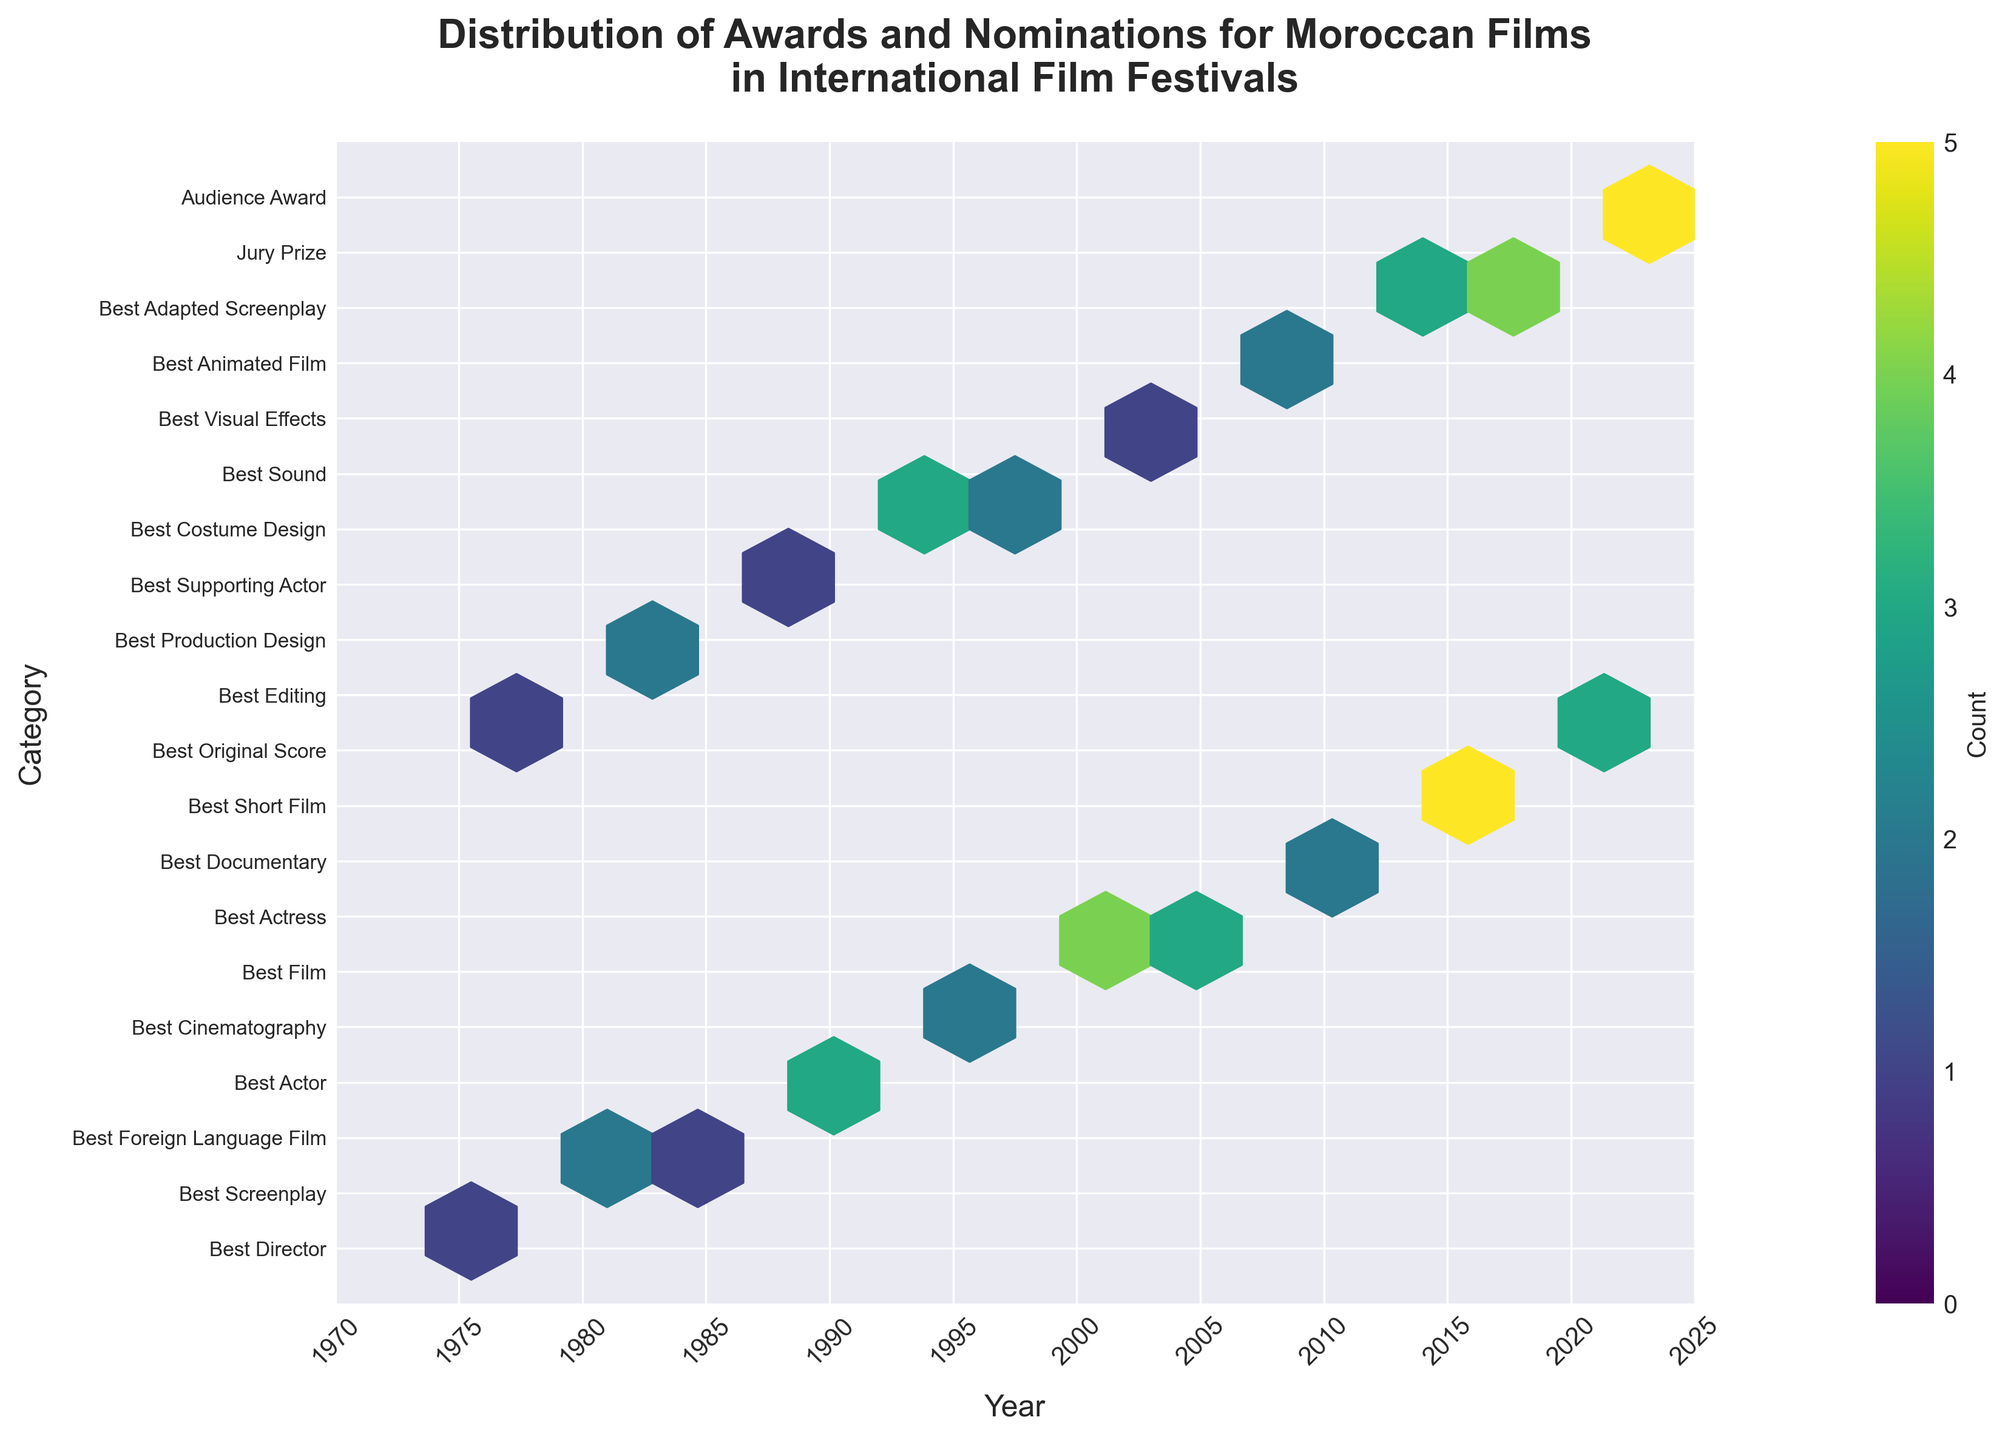What is the title of the figure? The title can be found at the top of the figure, which describes what the figure is about.
Answer: Distribution of Awards and Nominations for Moroccan Films in International Film Festivals What is the color range used in the hexbin plot? The color range usually denotes the count of awards and nominations, mapped to a colormap mentioned in the guide. The plot uses a color spectrum from the colormap indicated.
Answer: viridis What are the x-axis and y-axis labels? The labels can be found along the axes, describing what each axis represents.
Answer: Year and Category How many categories are present in the plot? Count the number of unique tick labels along the y-axis.
Answer: 20 Which category had the highest count of awards or nominations in 2015? Find the y-axis category that aligns with the hexbin on the x-axis value of 2015 and has the highest color intensity.
Answer: Best Short Film Is there a category that won awards or nominations consistently over many years? Look for categories on the y-axis that have multiple hexbins with higher counts spread across different years on the x-axis.
Answer: Examples would require specific attention, but count occurrences per category Does the plot show any award counts that are equal to 5? The color bar indicates the count of awards, locate the hexbins on the plot with the same color intensity as specified on the color bar reading 5.
Answer: Yes What was the count of "Best Adapted Screenplay" nominations in 2013? Match the y-axis of "Best Adapted Screenplay" with the x-axis of 2013 and read the color intensity count using the color bar.
Answer: 3 How does the count of nominations for "Best Actor" in 1990 compare with those for "Best Actress" in 2005? Locate the hexbin for "Best Actor" in 1990 and "Best Actress" in 2005, compare their color intensities.
Answer: Best Actor in 1990 has a higher count What trend can you observe about the overall number of awards and nominations over the years? Look at the distribution of hexbins from left to right on the x-axis for higher intensities to observe if there is an increase or decrease.
Answer: A general increase over the years 